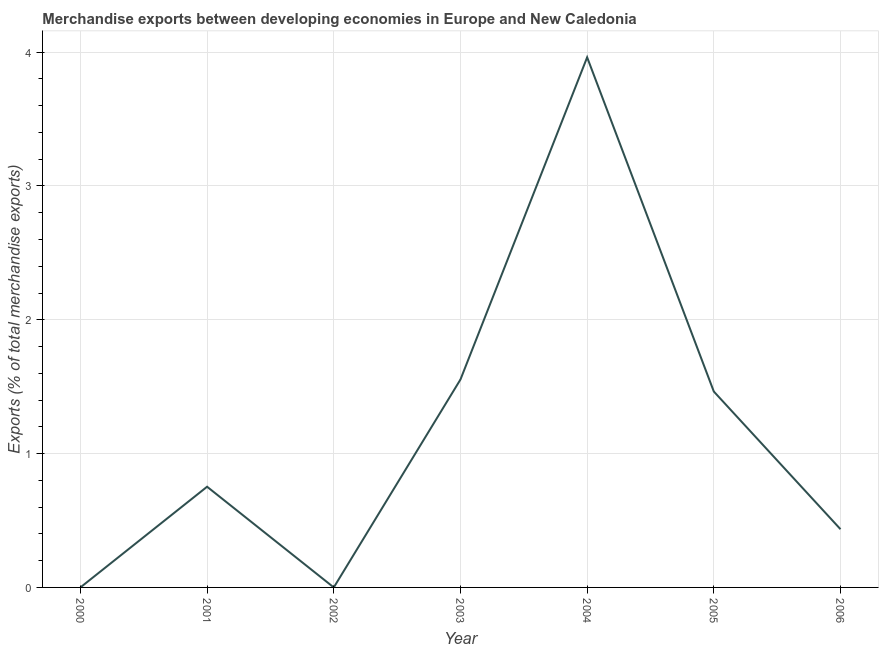What is the merchandise exports in 2000?
Ensure brevity in your answer.  0. Across all years, what is the maximum merchandise exports?
Keep it short and to the point. 3.96. Across all years, what is the minimum merchandise exports?
Your answer should be compact. 1.83457507108583e-6. What is the sum of the merchandise exports?
Provide a succinct answer. 8.17. What is the difference between the merchandise exports in 2002 and 2006?
Offer a terse response. -0.43. What is the average merchandise exports per year?
Provide a succinct answer. 1.17. What is the median merchandise exports?
Your answer should be compact. 0.75. In how many years, is the merchandise exports greater than 3 %?
Offer a very short reply. 1. Do a majority of the years between 2004 and 2000 (inclusive) have merchandise exports greater than 1.6 %?
Offer a very short reply. Yes. What is the ratio of the merchandise exports in 2005 to that in 2006?
Your response must be concise. 3.37. What is the difference between the highest and the second highest merchandise exports?
Keep it short and to the point. 2.41. Is the sum of the merchandise exports in 2001 and 2004 greater than the maximum merchandise exports across all years?
Offer a very short reply. Yes. What is the difference between the highest and the lowest merchandise exports?
Provide a short and direct response. 3.96. Does the merchandise exports monotonically increase over the years?
Your response must be concise. No. What is the difference between two consecutive major ticks on the Y-axis?
Your response must be concise. 1. Does the graph contain any zero values?
Your response must be concise. No. Does the graph contain grids?
Provide a short and direct response. Yes. What is the title of the graph?
Offer a very short reply. Merchandise exports between developing economies in Europe and New Caledonia. What is the label or title of the X-axis?
Give a very brief answer. Year. What is the label or title of the Y-axis?
Keep it short and to the point. Exports (% of total merchandise exports). What is the Exports (% of total merchandise exports) of 2000?
Your answer should be very brief. 0. What is the Exports (% of total merchandise exports) in 2001?
Your response must be concise. 0.75. What is the Exports (% of total merchandise exports) of 2002?
Provide a succinct answer. 1.83457507108583e-6. What is the Exports (% of total merchandise exports) in 2003?
Provide a short and direct response. 1.55. What is the Exports (% of total merchandise exports) in 2004?
Make the answer very short. 3.96. What is the Exports (% of total merchandise exports) in 2005?
Keep it short and to the point. 1.46. What is the Exports (% of total merchandise exports) of 2006?
Your answer should be very brief. 0.43. What is the difference between the Exports (% of total merchandise exports) in 2000 and 2001?
Your response must be concise. -0.75. What is the difference between the Exports (% of total merchandise exports) in 2000 and 2002?
Ensure brevity in your answer.  0. What is the difference between the Exports (% of total merchandise exports) in 2000 and 2003?
Your response must be concise. -1.55. What is the difference between the Exports (% of total merchandise exports) in 2000 and 2004?
Your response must be concise. -3.96. What is the difference between the Exports (% of total merchandise exports) in 2000 and 2005?
Make the answer very short. -1.46. What is the difference between the Exports (% of total merchandise exports) in 2000 and 2006?
Your answer should be compact. -0.43. What is the difference between the Exports (% of total merchandise exports) in 2001 and 2002?
Make the answer very short. 0.75. What is the difference between the Exports (% of total merchandise exports) in 2001 and 2003?
Your answer should be very brief. -0.8. What is the difference between the Exports (% of total merchandise exports) in 2001 and 2004?
Provide a succinct answer. -3.21. What is the difference between the Exports (% of total merchandise exports) in 2001 and 2005?
Offer a terse response. -0.71. What is the difference between the Exports (% of total merchandise exports) in 2001 and 2006?
Provide a short and direct response. 0.32. What is the difference between the Exports (% of total merchandise exports) in 2002 and 2003?
Make the answer very short. -1.55. What is the difference between the Exports (% of total merchandise exports) in 2002 and 2004?
Offer a very short reply. -3.96. What is the difference between the Exports (% of total merchandise exports) in 2002 and 2005?
Provide a short and direct response. -1.46. What is the difference between the Exports (% of total merchandise exports) in 2002 and 2006?
Your answer should be compact. -0.43. What is the difference between the Exports (% of total merchandise exports) in 2003 and 2004?
Keep it short and to the point. -2.41. What is the difference between the Exports (% of total merchandise exports) in 2003 and 2005?
Offer a terse response. 0.09. What is the difference between the Exports (% of total merchandise exports) in 2003 and 2006?
Your answer should be compact. 1.12. What is the difference between the Exports (% of total merchandise exports) in 2004 and 2005?
Provide a succinct answer. 2.5. What is the difference between the Exports (% of total merchandise exports) in 2004 and 2006?
Provide a succinct answer. 3.53. What is the difference between the Exports (% of total merchandise exports) in 2005 and 2006?
Your answer should be compact. 1.03. What is the ratio of the Exports (% of total merchandise exports) in 2000 to that in 2002?
Give a very brief answer. 89.61. What is the ratio of the Exports (% of total merchandise exports) in 2000 to that in 2006?
Make the answer very short. 0. What is the ratio of the Exports (% of total merchandise exports) in 2001 to that in 2002?
Keep it short and to the point. 4.10e+05. What is the ratio of the Exports (% of total merchandise exports) in 2001 to that in 2003?
Your answer should be compact. 0.48. What is the ratio of the Exports (% of total merchandise exports) in 2001 to that in 2004?
Provide a short and direct response. 0.19. What is the ratio of the Exports (% of total merchandise exports) in 2001 to that in 2005?
Offer a very short reply. 0.51. What is the ratio of the Exports (% of total merchandise exports) in 2001 to that in 2006?
Keep it short and to the point. 1.73. What is the ratio of the Exports (% of total merchandise exports) in 2002 to that in 2004?
Your answer should be very brief. 0. What is the ratio of the Exports (% of total merchandise exports) in 2002 to that in 2006?
Ensure brevity in your answer.  0. What is the ratio of the Exports (% of total merchandise exports) in 2003 to that in 2004?
Provide a succinct answer. 0.39. What is the ratio of the Exports (% of total merchandise exports) in 2003 to that in 2005?
Your answer should be very brief. 1.06. What is the ratio of the Exports (% of total merchandise exports) in 2003 to that in 2006?
Offer a terse response. 3.57. What is the ratio of the Exports (% of total merchandise exports) in 2004 to that in 2005?
Make the answer very short. 2.71. What is the ratio of the Exports (% of total merchandise exports) in 2004 to that in 2006?
Provide a succinct answer. 9.11. What is the ratio of the Exports (% of total merchandise exports) in 2005 to that in 2006?
Offer a very short reply. 3.37. 